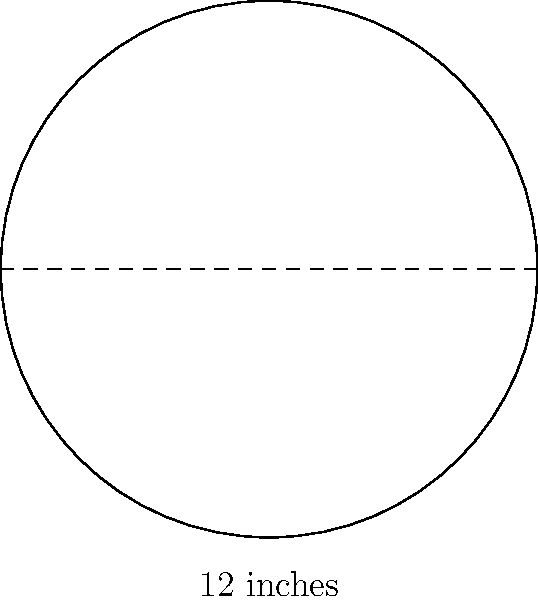You've just acquired a rare vinyl record and want to calculate its surface area. The record has a diameter of 12 inches. What is the total surface area of the vinyl record in square inches? (Use $\pi \approx 3.14$ and round your answer to the nearest whole number.) Let's approach this step-by-step:

1) First, we need to recall the formula for the area of a circle:
   $A = \pi r^2$, where $r$ is the radius

2) We're given the diameter, which is 12 inches. The radius is half of the diameter:
   $r = 12 \div 2 = 6$ inches

3) Now we can plug this into our formula:
   $A = \pi (6)^2$

4) Simplify:
   $A = \pi (36)$

5) We're told to use $\pi \approx 3.14$:
   $A \approx 3.14 (36)$

6) Calculate:
   $A \approx 113.04$ square inches

7) Rounding to the nearest whole number:
   $A \approx 113$ square inches

Therefore, the surface area of the vinyl record is approximately 113 square inches.
Answer: 113 square inches 